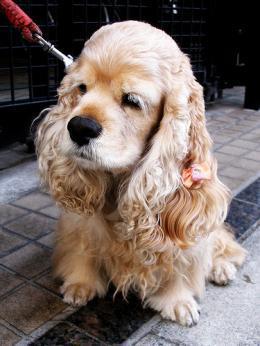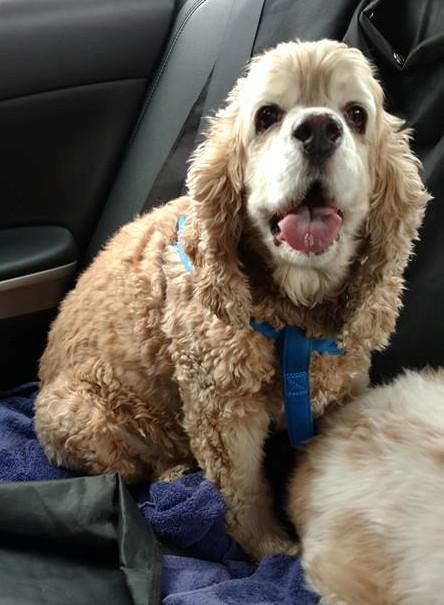The first image is the image on the left, the second image is the image on the right. Considering the images on both sides, is "An image shows exactly two red-orange dogs side-by-side." valid? Answer yes or no. No. 